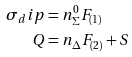Convert formula to latex. <formula><loc_0><loc_0><loc_500><loc_500>\sigma _ { d } i p & = n _ { \Sigma } ^ { 0 } F _ { ( 1 ) } \\ Q & = n _ { \Delta } F _ { ( 2 ) } + S</formula> 